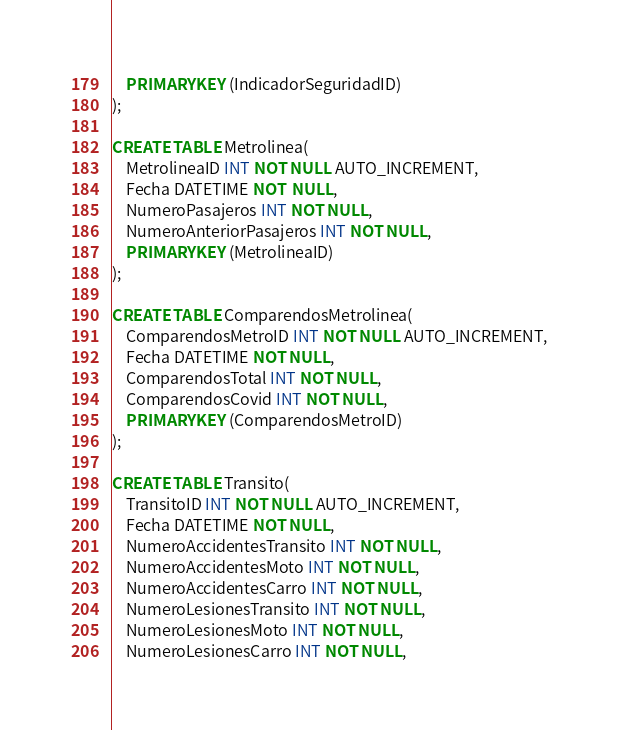<code> <loc_0><loc_0><loc_500><loc_500><_SQL_>    PRIMARY KEY (IndicadorSeguridadID)
);

CREATE TABLE Metrolinea(
    MetrolineaID INT NOT NULL AUTO_INCREMENT,
    Fecha DATETIME NOT  NULL,
    NumeroPasajeros INT NOT NULL,
    NumeroAnteriorPasajeros INT NOT NULL,
    PRIMARY KEY (MetrolineaID)
);

CREATE TABLE ComparendosMetrolinea(
    ComparendosMetroID INT NOT NULL AUTO_INCREMENT,
    Fecha DATETIME NOT NULL,
    ComparendosTotal INT NOT NULL,
    ComparendosCovid INT NOT NULL,
    PRIMARY KEY (ComparendosMetroID)
);

CREATE TABLE Transito(
    TransitoID INT NOT NULL AUTO_INCREMENT,
    Fecha DATETIME NOT NULL,
    NumeroAccidentesTransito INT NOT NULL,
    NumeroAccidentesMoto INT NOT NULL,
    NumeroAccidentesCarro INT NOT NULL,
    NumeroLesionesTransito INT NOT NULL,
    NumeroLesionesMoto INT NOT NULL,
    NumeroLesionesCarro INT NOT NULL,</code> 